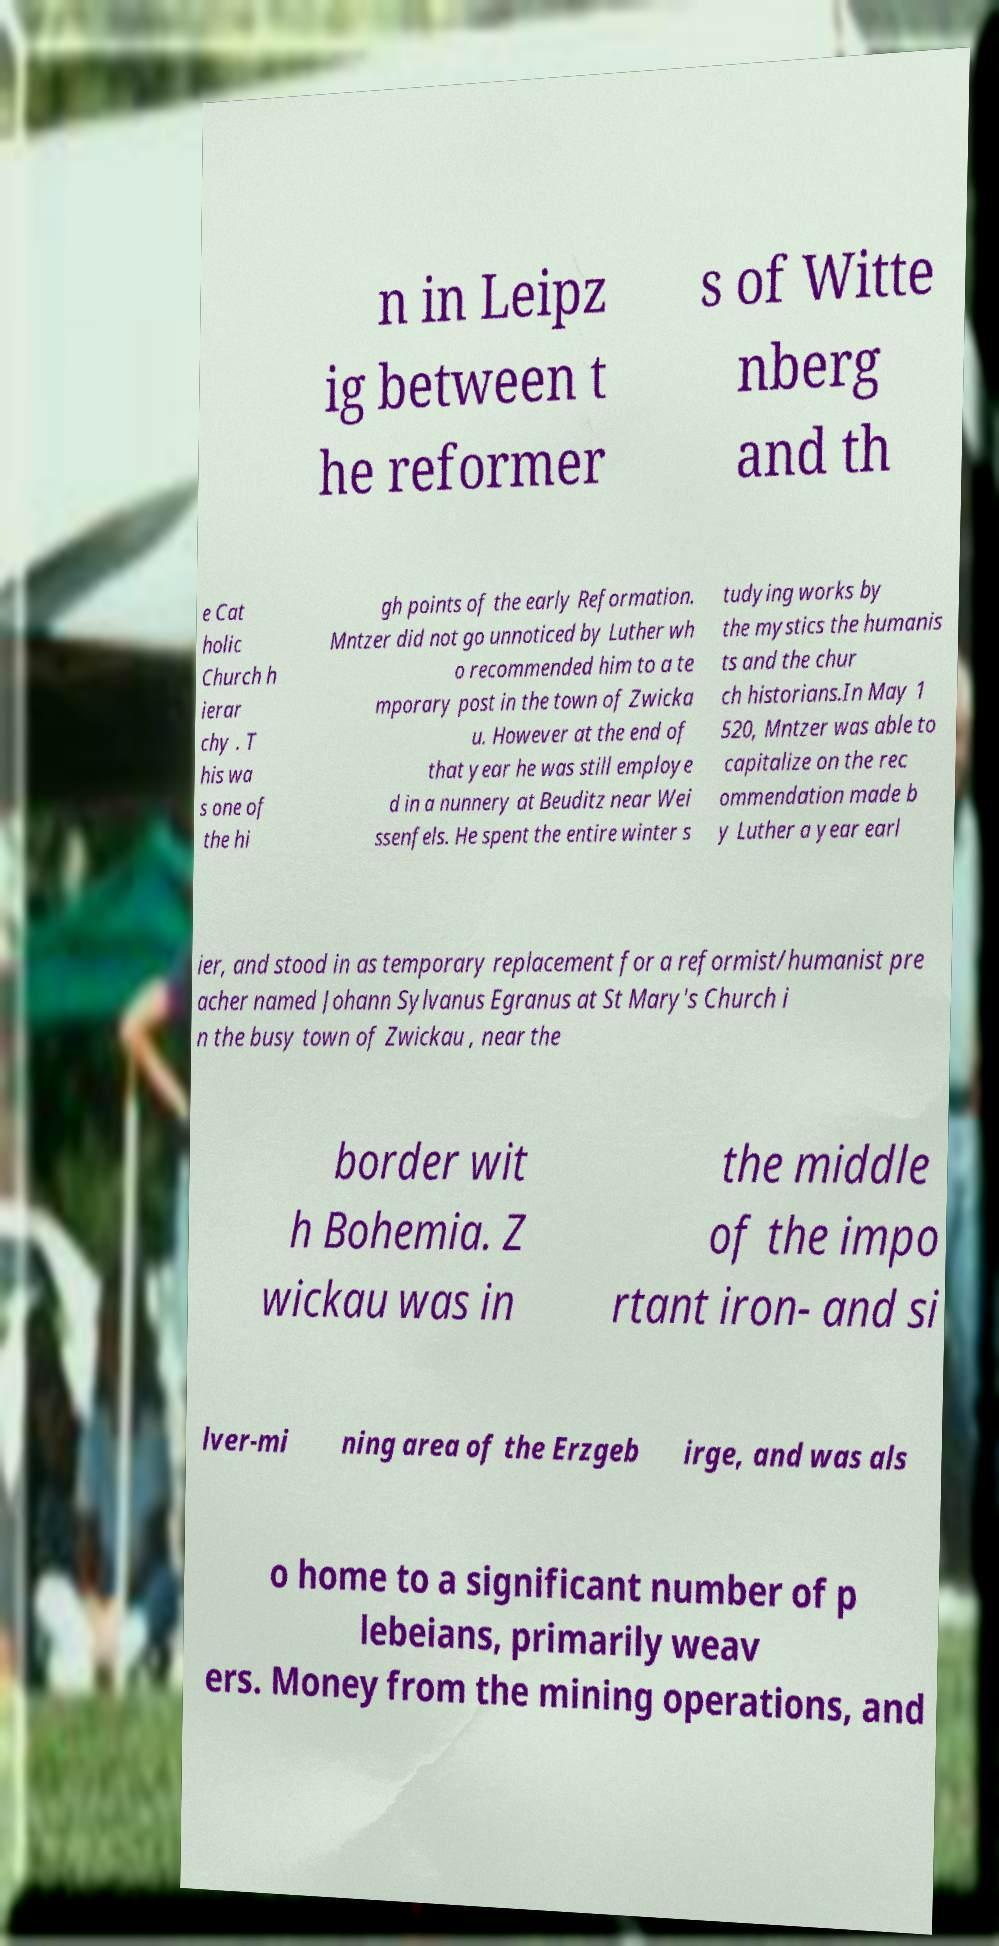For documentation purposes, I need the text within this image transcribed. Could you provide that? n in Leipz ig between t he reformer s of Witte nberg and th e Cat holic Church h ierar chy . T his wa s one of the hi gh points of the early Reformation. Mntzer did not go unnoticed by Luther wh o recommended him to a te mporary post in the town of Zwicka u. However at the end of that year he was still employe d in a nunnery at Beuditz near Wei ssenfels. He spent the entire winter s tudying works by the mystics the humanis ts and the chur ch historians.In May 1 520, Mntzer was able to capitalize on the rec ommendation made b y Luther a year earl ier, and stood in as temporary replacement for a reformist/humanist pre acher named Johann Sylvanus Egranus at St Mary's Church i n the busy town of Zwickau , near the border wit h Bohemia. Z wickau was in the middle of the impo rtant iron- and si lver-mi ning area of the Erzgeb irge, and was als o home to a significant number of p lebeians, primarily weav ers. Money from the mining operations, and 